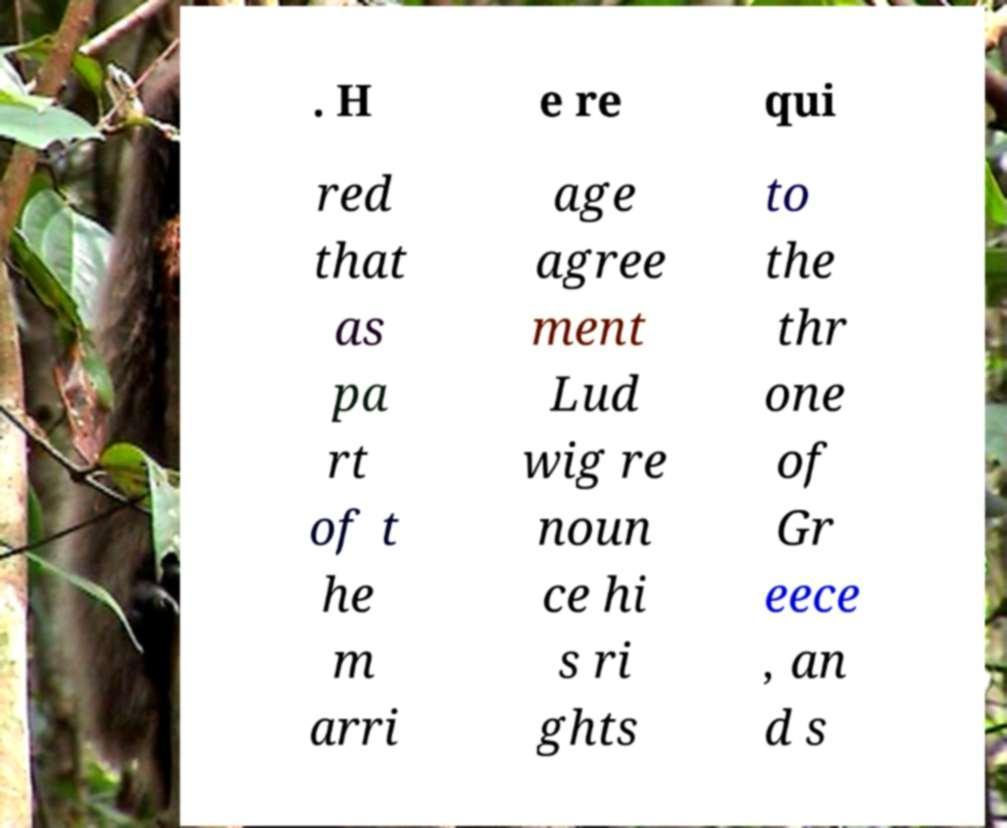There's text embedded in this image that I need extracted. Can you transcribe it verbatim? . H e re qui red that as pa rt of t he m arri age agree ment Lud wig re noun ce hi s ri ghts to the thr one of Gr eece , an d s 